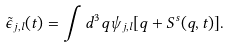<formula> <loc_0><loc_0><loc_500><loc_500>\tilde { \epsilon } _ { j , l } ( t ) = \int d ^ { 3 } q \psi _ { j , l } [ { q } + { S ^ { s } ( q } , t ) ] .</formula> 